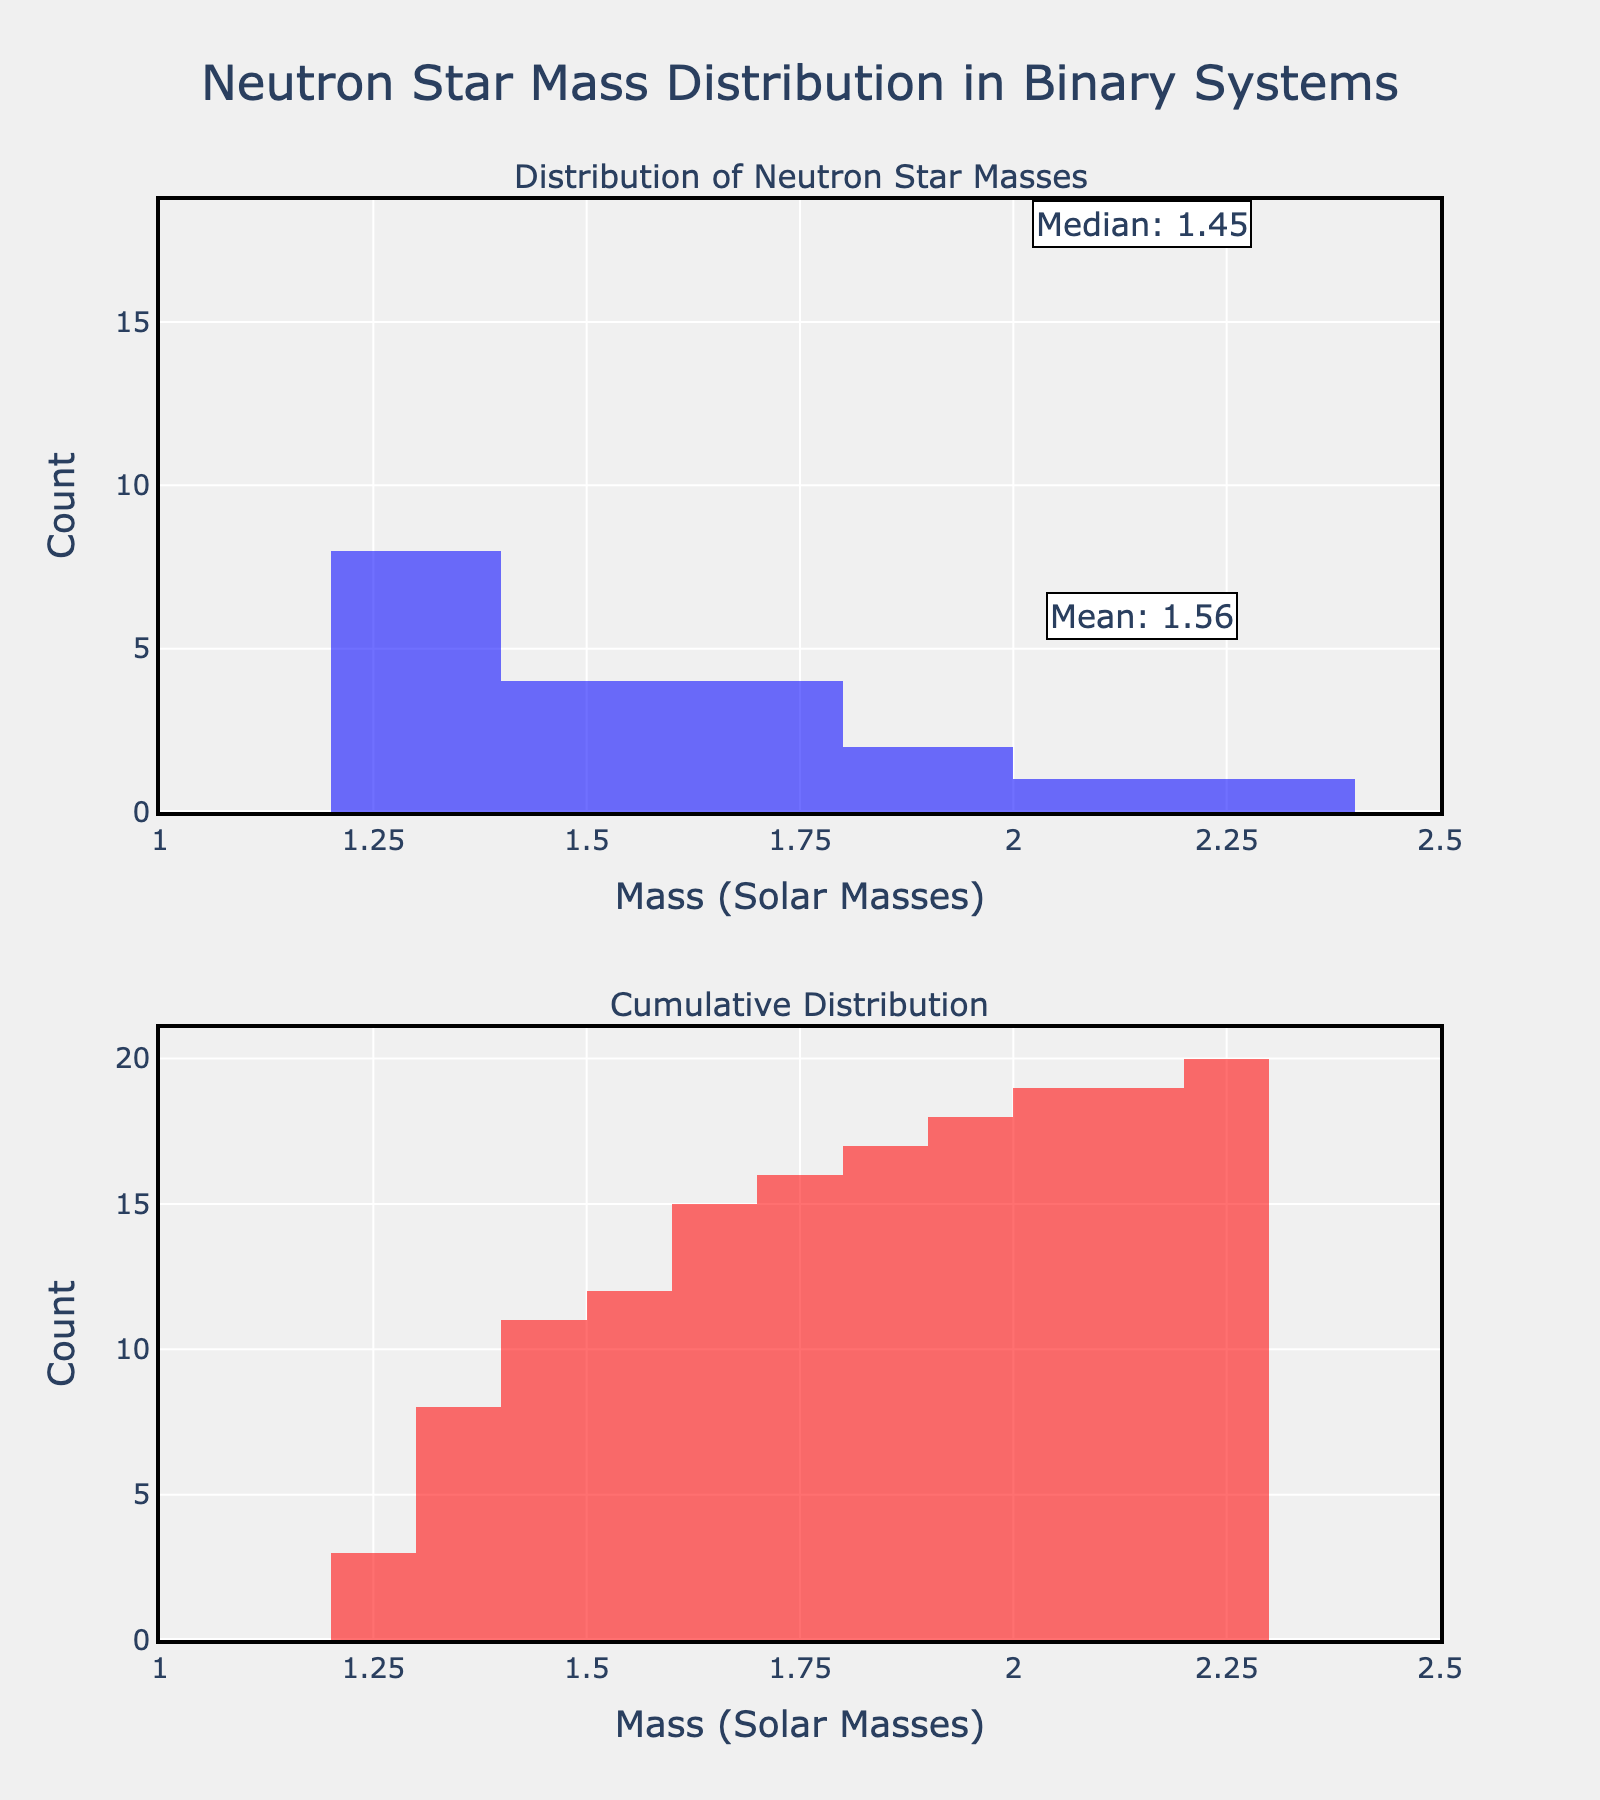What is the title of the figure? The title is located at the top center of the figure and is displayed in large font.
Answer: Neutron Star Mass Distribution in Binary Systems How many bins are used in the first histogram (top subplot)? The figure divides the data into specific sections or bins. The number of these sections is visible in the top subplot.
Answer: 10 What do the colors blue and red represent in the figure? By looking at the figure, one can see that different colors are used for different subplots. Blue is used for the mass distribution while red is used for the cumulative distribution.
Answer: Blue represents Mass Distribution, and red represents Cumulative Distribution What is the mean mass of the neutron stars, according to the annotations? The figure has an annotation in the top histogram with a specific value for the mean mass.
Answer: 1.56 How does the median compare to the mean mass of neutron stars? Both the mean and median values of neutron star masses are annotated in the top histogram, allowing for a direct comparison.
Answer: The median is slightly higher than the mean Which axis represents the mass of neutron stars in solar masses? The x-axis, described by its label and tick marks.
Answer: X-axis Where does the highest frequency of neutron star masses fall within the range of 1 to 2.5 solar masses? By observing the top histogram, one can see the bin with the highest frequency.
Answer: Around 1.3 to 1.4 solar masses What can you infer from the cumulative distribution histogram about the number of neutron stars with a mass less than or equal to 1.5 solar masses? The cumulative histogram shows the cumulative count as the mass increases. At mass = 1.5 solar masses, the y-axis indicates how many neutron stars are at or below this mass.
Answer: More than half of the neutron stars Which neutron star system observed has the highest mass? The red cumulative histogram in the bottom subplot shows a gradual increase. The steepest increase is seen at a specific mass value.
Answer: PSR J2215+5135 What is the tick interval on the x-axis and y-axis of the histogram? By examining the axes, you can determine that the horizontal spacing (tick interval) between the values is 0.25 and the vertical spacing is 1.0.
Answer: 0.25 (x-axis) and 1.0 (y-axis) 